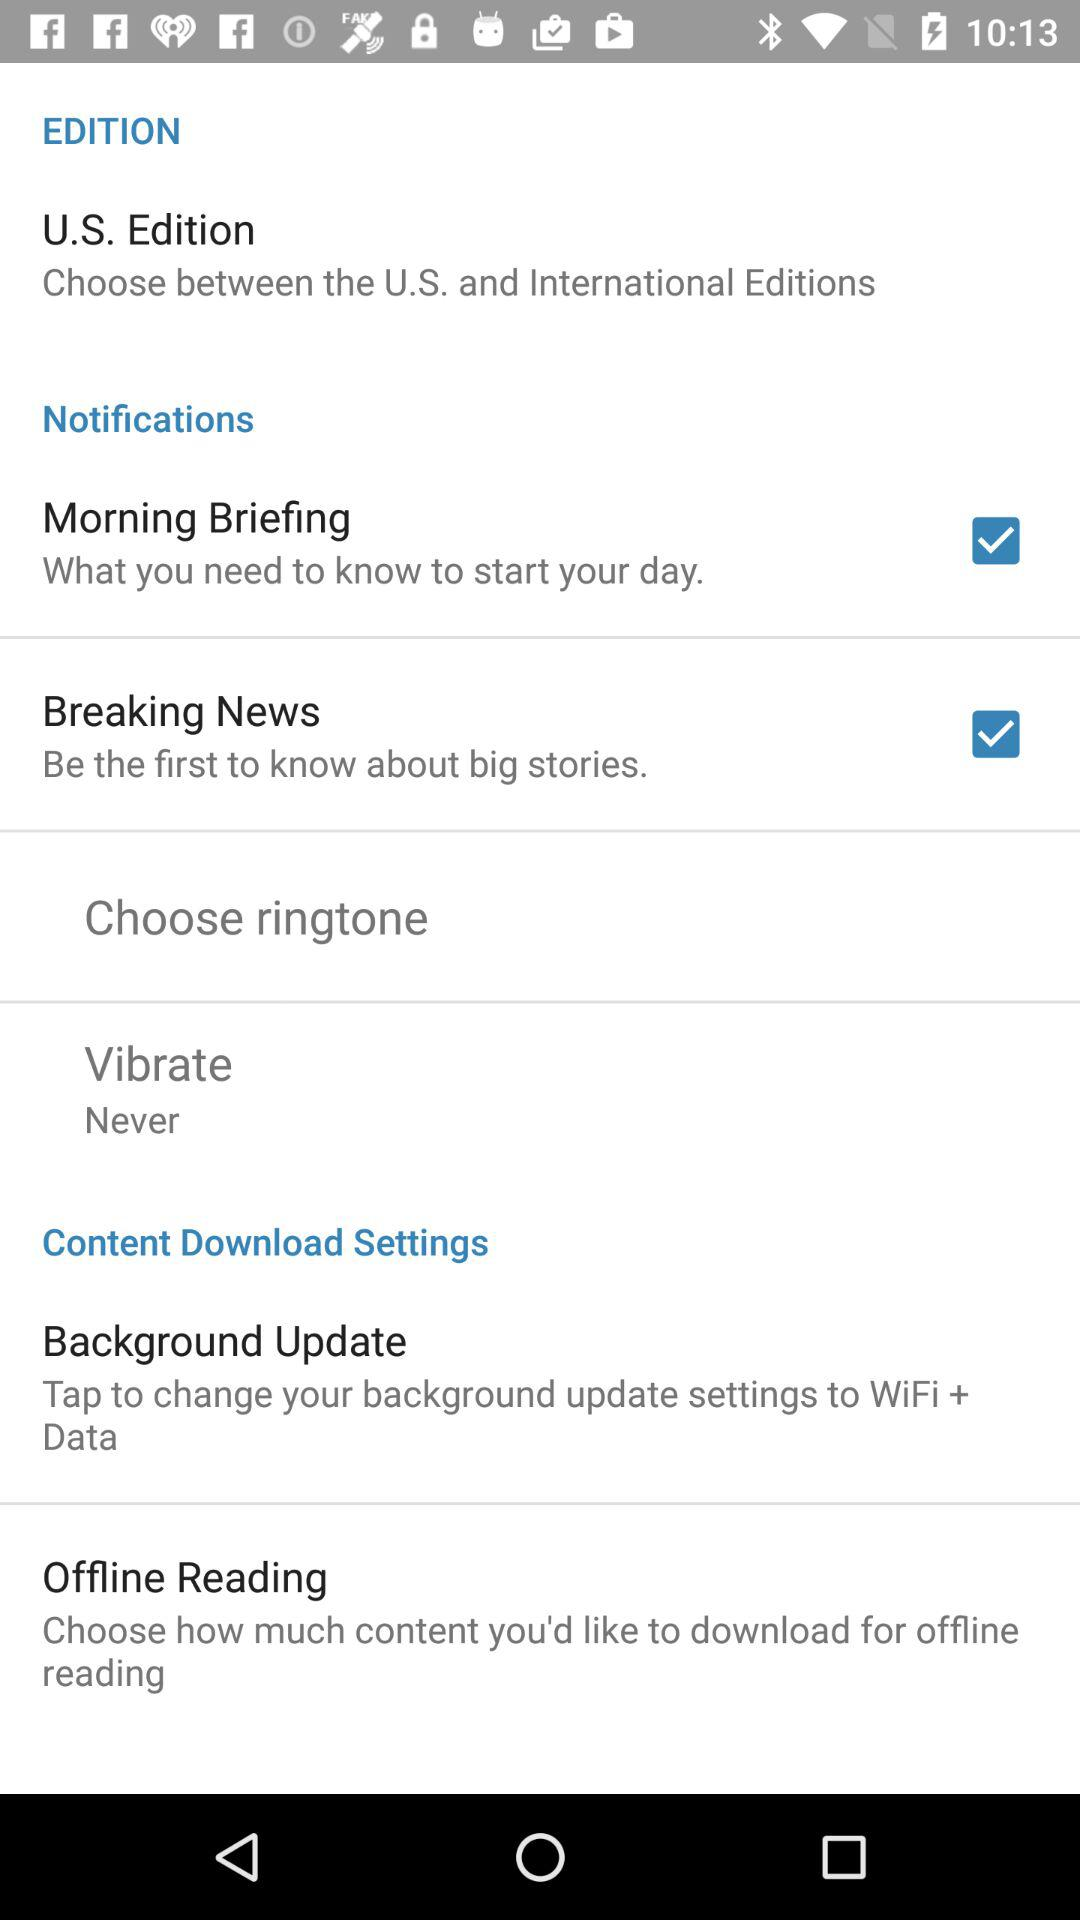Which is the chosen edition? The chosen edition is the "U.S. Edition". 